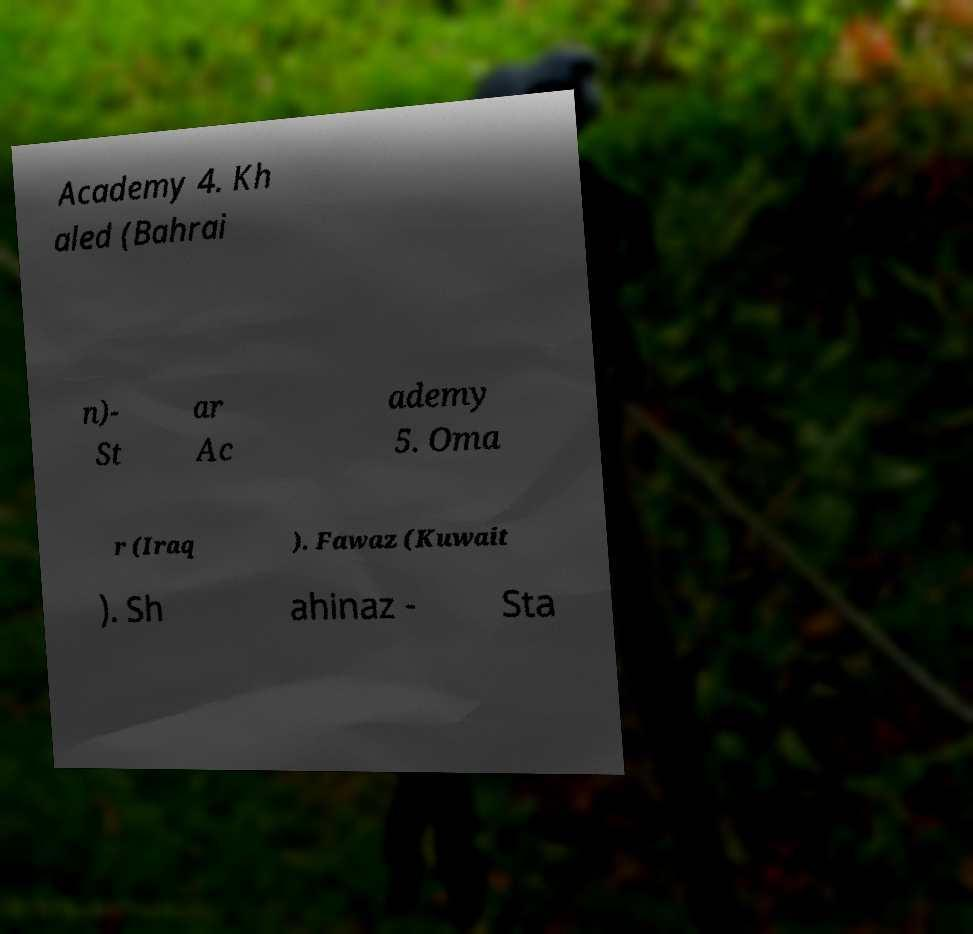Please identify and transcribe the text found in this image. Academy 4. Kh aled (Bahrai n)- St ar Ac ademy 5. Oma r (Iraq ). Fawaz (Kuwait ). Sh ahinaz - Sta 